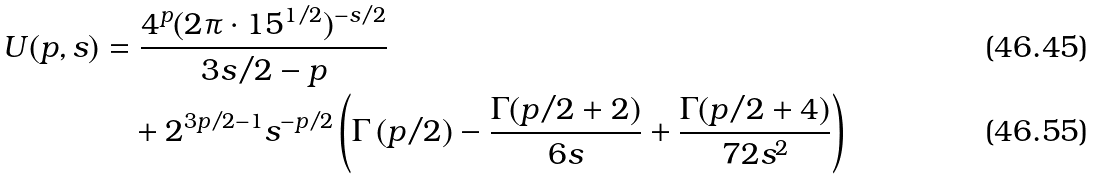Convert formula to latex. <formula><loc_0><loc_0><loc_500><loc_500>U ( p , s ) & = \frac { 4 ^ { p } ( 2 \pi \cdot 1 5 ^ { 1 / 2 } ) ^ { - s / 2 } } { 3 s / 2 - p } \\ & \quad + 2 ^ { 3 p / 2 - 1 } s ^ { - p / 2 } \left ( \Gamma \left ( p / 2 \right ) - \frac { \Gamma ( p / 2 + 2 ) } { 6 s } + \frac { \Gamma ( p / 2 + 4 ) } { 7 2 s ^ { 2 } } \right )</formula> 